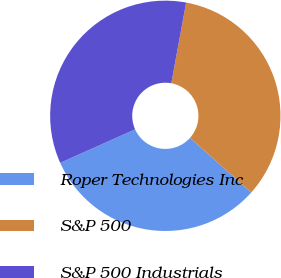<chart> <loc_0><loc_0><loc_500><loc_500><pie_chart><fcel>Roper Technologies Inc<fcel>S&P 500<fcel>S&P 500 Industrials<nl><fcel>31.71%<fcel>33.7%<fcel>34.59%<nl></chart> 